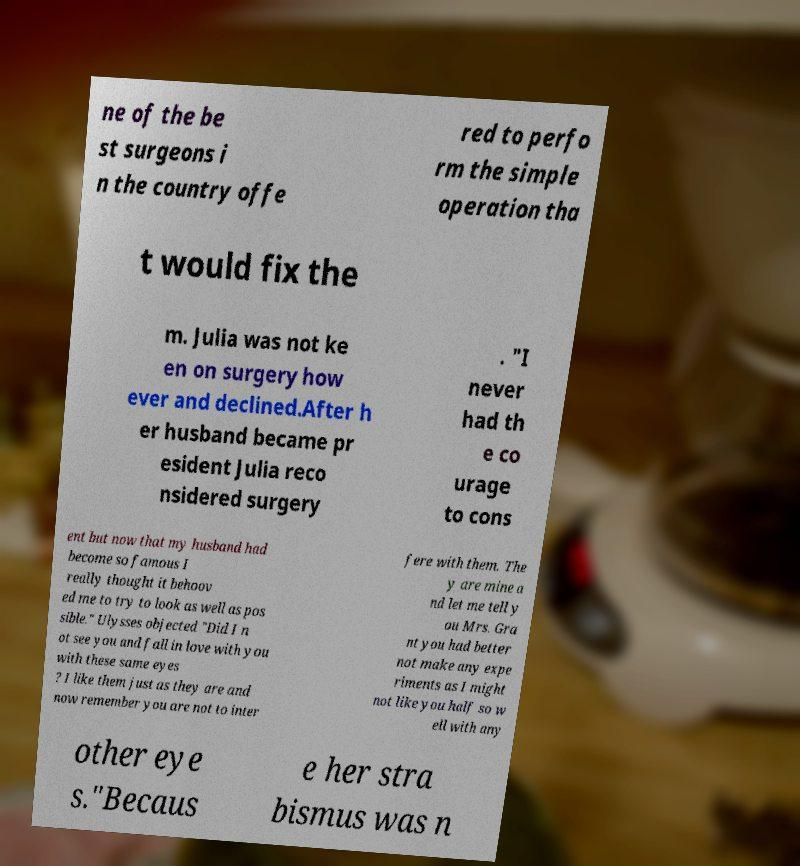Can you read and provide the text displayed in the image?This photo seems to have some interesting text. Can you extract and type it out for me? ne of the be st surgeons i n the country offe red to perfo rm the simple operation tha t would fix the m. Julia was not ke en on surgery how ever and declined.After h er husband became pr esident Julia reco nsidered surgery . "I never had th e co urage to cons ent but now that my husband had become so famous I really thought it behoov ed me to try to look as well as pos sible." Ulysses objected "Did I n ot see you and fall in love with you with these same eyes ? I like them just as they are and now remember you are not to inter fere with them. The y are mine a nd let me tell y ou Mrs. Gra nt you had better not make any expe riments as I might not like you half so w ell with any other eye s."Becaus e her stra bismus was n 